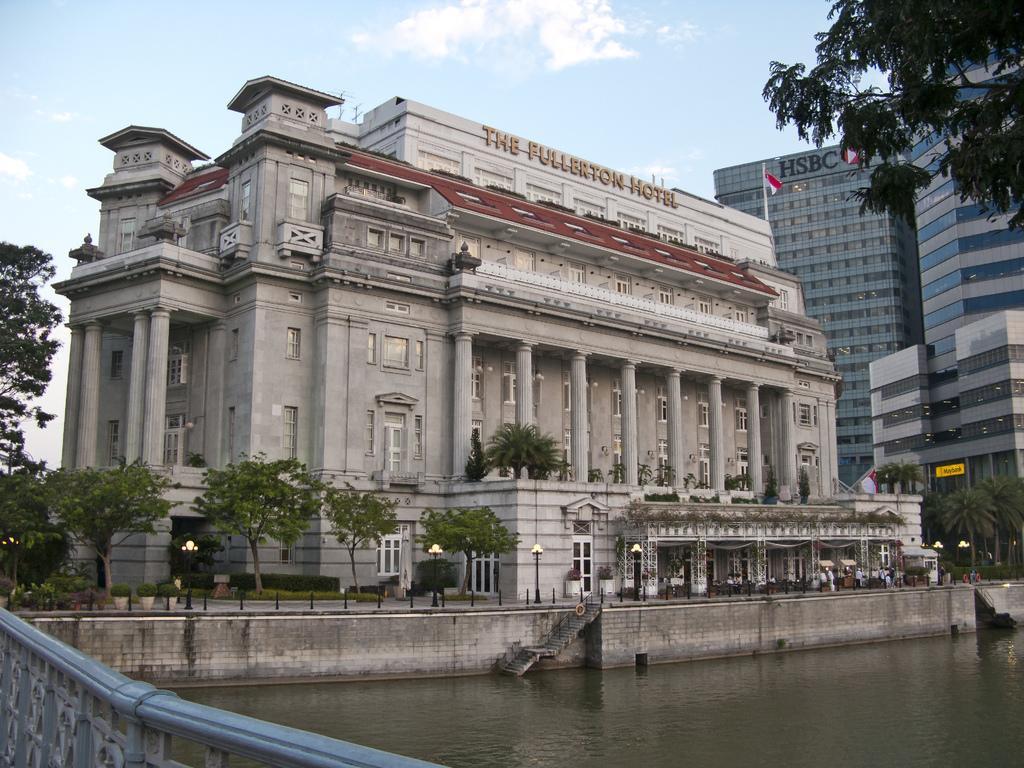Could you give a brief overview of what you see in this image? In this image I can see buildings. There are trees, stairs, lights, iron poles and there is a pole with flag. Also there is water, fencing and in the background there is sky. 